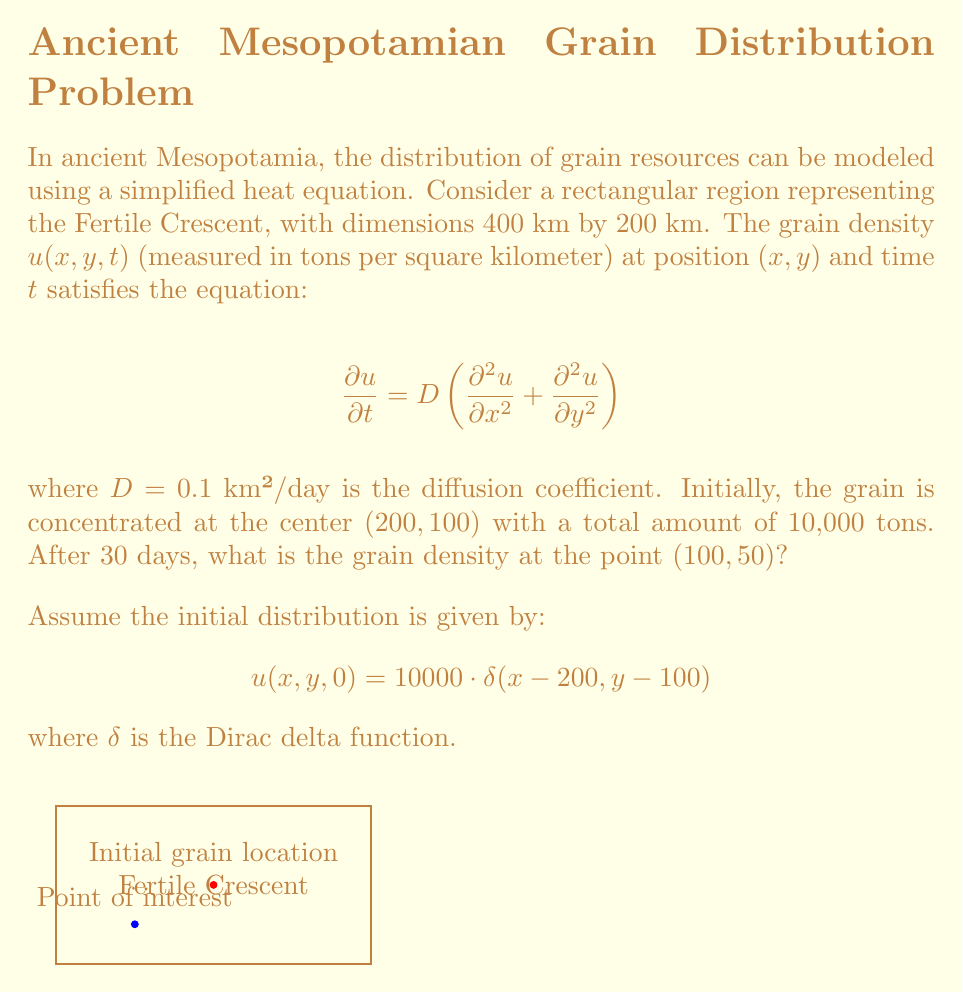Give your solution to this math problem. To solve this problem, we'll follow these steps:

1) The solution to the 2D heat equation with an initial point source is given by:

   $$u(x,y,t) = \frac{M}{4\pi Dt} \exp\left(-\frac{(x-x_0)^2 + (y-y_0)^2}{4Dt}\right)$$

   where $M$ is the total mass, $(x_0,y_0)$ is the initial point source location, and $t$ is time.

2) In our case:
   $M = 10000$ tons
   $(x_0,y_0) = (200,100)$ km
   $D = 0.1$ km²/day
   $t = 30$ days
   $(x,y) = (100,50)$ km

3) Let's substitute these values:

   $$u(100,50,30) = \frac{10000}{4\pi \cdot 0.1 \cdot 30} \exp\left(-\frac{(100-200)^2 + (50-100)^2}{4 \cdot 0.1 \cdot 30}\right)$$

4) Simplify:
   $$u(100,50,30) = \frac{10000}{37.7} \exp\left(-\frac{12500}{12}\right)$$

5) Calculate:
   $$u(100,50,30) \approx 265.25 \cdot 0.0188 \approx 4.99 \text{ tons/km²}$$
Answer: $4.99$ tons/km² 